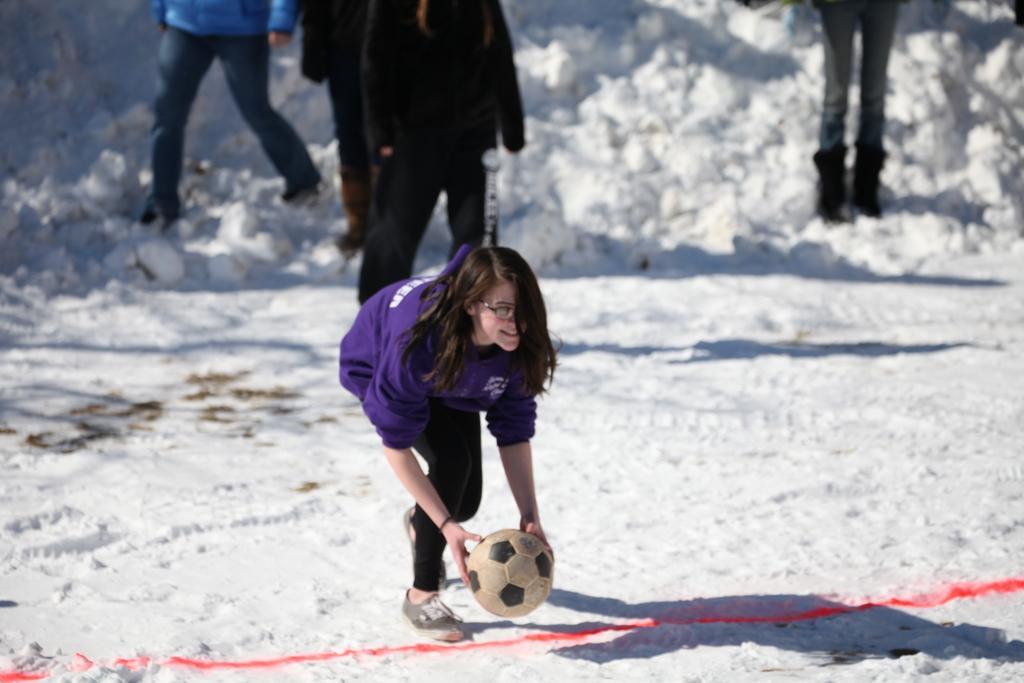Can you describe this image briefly? Here we can see a woman having a football in her hand and behind her we can see group of people standing and it is snowy 